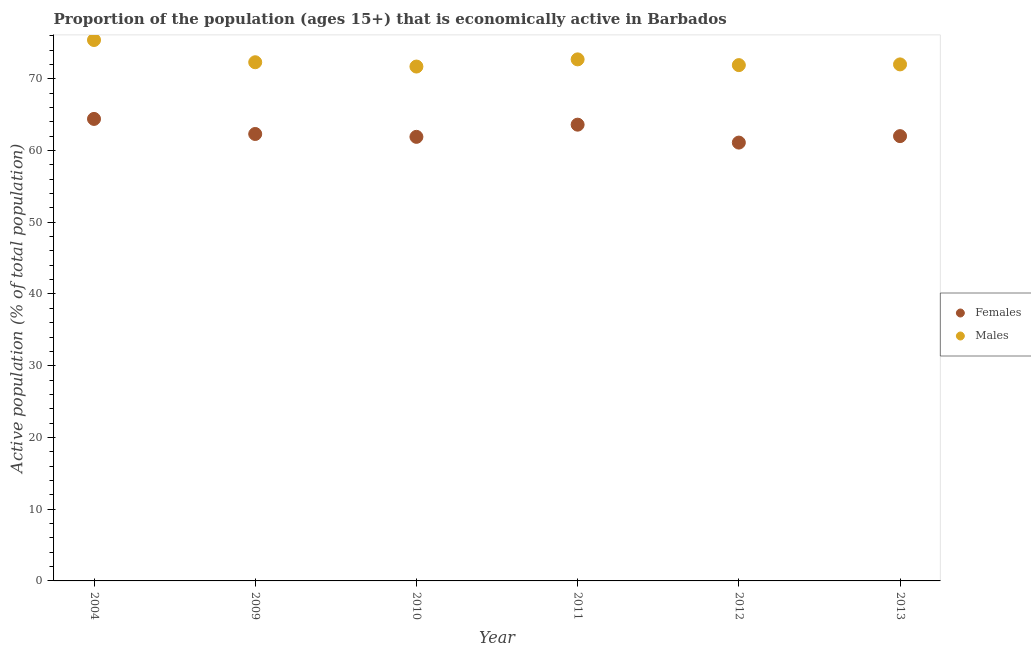How many different coloured dotlines are there?
Your response must be concise. 2. What is the percentage of economically active male population in 2004?
Your answer should be very brief. 75.4. Across all years, what is the maximum percentage of economically active male population?
Your answer should be compact. 75.4. Across all years, what is the minimum percentage of economically active female population?
Your answer should be compact. 61.1. In which year was the percentage of economically active female population maximum?
Keep it short and to the point. 2004. What is the total percentage of economically active male population in the graph?
Your response must be concise. 436. What is the difference between the percentage of economically active female population in 2010 and that in 2011?
Make the answer very short. -1.7. What is the difference between the percentage of economically active male population in 2011 and the percentage of economically active female population in 2013?
Offer a terse response. 10.7. What is the average percentage of economically active male population per year?
Make the answer very short. 72.67. In the year 2011, what is the difference between the percentage of economically active female population and percentage of economically active male population?
Your answer should be very brief. -9.1. In how many years, is the percentage of economically active female population greater than 64 %?
Ensure brevity in your answer.  1. What is the ratio of the percentage of economically active male population in 2004 to that in 2010?
Your answer should be very brief. 1.05. Is the percentage of economically active male population in 2004 less than that in 2012?
Provide a short and direct response. No. Is the difference between the percentage of economically active female population in 2010 and 2011 greater than the difference between the percentage of economically active male population in 2010 and 2011?
Ensure brevity in your answer.  No. What is the difference between the highest and the second highest percentage of economically active female population?
Your answer should be compact. 0.8. What is the difference between the highest and the lowest percentage of economically active female population?
Keep it short and to the point. 3.3. Does the percentage of economically active male population monotonically increase over the years?
Offer a very short reply. No. Is the percentage of economically active male population strictly greater than the percentage of economically active female population over the years?
Your answer should be compact. Yes. What is the difference between two consecutive major ticks on the Y-axis?
Keep it short and to the point. 10. Where does the legend appear in the graph?
Provide a succinct answer. Center right. How are the legend labels stacked?
Your response must be concise. Vertical. What is the title of the graph?
Provide a succinct answer. Proportion of the population (ages 15+) that is economically active in Barbados. What is the label or title of the Y-axis?
Your answer should be compact. Active population (% of total population). What is the Active population (% of total population) in Females in 2004?
Keep it short and to the point. 64.4. What is the Active population (% of total population) of Males in 2004?
Your answer should be very brief. 75.4. What is the Active population (% of total population) of Females in 2009?
Your answer should be compact. 62.3. What is the Active population (% of total population) of Males in 2009?
Provide a succinct answer. 72.3. What is the Active population (% of total population) of Females in 2010?
Offer a very short reply. 61.9. What is the Active population (% of total population) of Males in 2010?
Your response must be concise. 71.7. What is the Active population (% of total population) of Females in 2011?
Provide a short and direct response. 63.6. What is the Active population (% of total population) of Males in 2011?
Offer a very short reply. 72.7. What is the Active population (% of total population) of Females in 2012?
Provide a short and direct response. 61.1. What is the Active population (% of total population) of Males in 2012?
Provide a short and direct response. 71.9. What is the Active population (% of total population) of Males in 2013?
Provide a succinct answer. 72. Across all years, what is the maximum Active population (% of total population) of Females?
Give a very brief answer. 64.4. Across all years, what is the maximum Active population (% of total population) in Males?
Your response must be concise. 75.4. Across all years, what is the minimum Active population (% of total population) in Females?
Your answer should be compact. 61.1. Across all years, what is the minimum Active population (% of total population) of Males?
Provide a succinct answer. 71.7. What is the total Active population (% of total population) of Females in the graph?
Ensure brevity in your answer.  375.3. What is the total Active population (% of total population) in Males in the graph?
Your response must be concise. 436. What is the difference between the Active population (% of total population) of Females in 2004 and that in 2009?
Offer a terse response. 2.1. What is the difference between the Active population (% of total population) in Females in 2004 and that in 2010?
Provide a short and direct response. 2.5. What is the difference between the Active population (% of total population) in Females in 2004 and that in 2012?
Your answer should be compact. 3.3. What is the difference between the Active population (% of total population) of Males in 2004 and that in 2012?
Your response must be concise. 3.5. What is the difference between the Active population (% of total population) in Males in 2009 and that in 2010?
Your response must be concise. 0.6. What is the difference between the Active population (% of total population) of Males in 2009 and that in 2011?
Make the answer very short. -0.4. What is the difference between the Active population (% of total population) in Females in 2009 and that in 2012?
Offer a terse response. 1.2. What is the difference between the Active population (% of total population) of Males in 2009 and that in 2012?
Provide a short and direct response. 0.4. What is the difference between the Active population (% of total population) of Females in 2009 and that in 2013?
Keep it short and to the point. 0.3. What is the difference between the Active population (% of total population) of Males in 2009 and that in 2013?
Provide a succinct answer. 0.3. What is the difference between the Active population (% of total population) in Males in 2010 and that in 2011?
Provide a short and direct response. -1. What is the difference between the Active population (% of total population) in Females in 2010 and that in 2012?
Offer a very short reply. 0.8. What is the difference between the Active population (% of total population) of Males in 2010 and that in 2012?
Your answer should be compact. -0.2. What is the difference between the Active population (% of total population) of Females in 2010 and that in 2013?
Make the answer very short. -0.1. What is the difference between the Active population (% of total population) in Males in 2010 and that in 2013?
Make the answer very short. -0.3. What is the difference between the Active population (% of total population) in Males in 2011 and that in 2012?
Offer a terse response. 0.8. What is the difference between the Active population (% of total population) in Females in 2011 and that in 2013?
Your answer should be very brief. 1.6. What is the difference between the Active population (% of total population) in Males in 2012 and that in 2013?
Ensure brevity in your answer.  -0.1. What is the difference between the Active population (% of total population) in Females in 2004 and the Active population (% of total population) in Males in 2009?
Your response must be concise. -7.9. What is the difference between the Active population (% of total population) of Females in 2004 and the Active population (% of total population) of Males in 2010?
Ensure brevity in your answer.  -7.3. What is the difference between the Active population (% of total population) in Females in 2004 and the Active population (% of total population) in Males in 2012?
Keep it short and to the point. -7.5. What is the difference between the Active population (% of total population) of Females in 2004 and the Active population (% of total population) of Males in 2013?
Your response must be concise. -7.6. What is the difference between the Active population (% of total population) of Females in 2009 and the Active population (% of total population) of Males in 2010?
Offer a very short reply. -9.4. What is the difference between the Active population (% of total population) of Females in 2009 and the Active population (% of total population) of Males in 2012?
Provide a succinct answer. -9.6. What is the difference between the Active population (% of total population) in Females in 2010 and the Active population (% of total population) in Males in 2012?
Make the answer very short. -10. What is the difference between the Active population (% of total population) in Females in 2010 and the Active population (% of total population) in Males in 2013?
Offer a terse response. -10.1. What is the average Active population (% of total population) of Females per year?
Offer a terse response. 62.55. What is the average Active population (% of total population) in Males per year?
Give a very brief answer. 72.67. In the year 2010, what is the difference between the Active population (% of total population) in Females and Active population (% of total population) in Males?
Ensure brevity in your answer.  -9.8. What is the ratio of the Active population (% of total population) in Females in 2004 to that in 2009?
Make the answer very short. 1.03. What is the ratio of the Active population (% of total population) of Males in 2004 to that in 2009?
Your answer should be very brief. 1.04. What is the ratio of the Active population (% of total population) in Females in 2004 to that in 2010?
Ensure brevity in your answer.  1.04. What is the ratio of the Active population (% of total population) in Males in 2004 to that in 2010?
Provide a short and direct response. 1.05. What is the ratio of the Active population (% of total population) in Females in 2004 to that in 2011?
Your answer should be compact. 1.01. What is the ratio of the Active population (% of total population) in Males in 2004 to that in 2011?
Your answer should be very brief. 1.04. What is the ratio of the Active population (% of total population) in Females in 2004 to that in 2012?
Your response must be concise. 1.05. What is the ratio of the Active population (% of total population) in Males in 2004 to that in 2012?
Offer a very short reply. 1.05. What is the ratio of the Active population (% of total population) of Females in 2004 to that in 2013?
Your answer should be compact. 1.04. What is the ratio of the Active population (% of total population) of Males in 2004 to that in 2013?
Provide a short and direct response. 1.05. What is the ratio of the Active population (% of total population) of Females in 2009 to that in 2010?
Your answer should be very brief. 1.01. What is the ratio of the Active population (% of total population) of Males in 2009 to that in 2010?
Offer a very short reply. 1.01. What is the ratio of the Active population (% of total population) in Females in 2009 to that in 2011?
Offer a very short reply. 0.98. What is the ratio of the Active population (% of total population) of Males in 2009 to that in 2011?
Provide a succinct answer. 0.99. What is the ratio of the Active population (% of total population) in Females in 2009 to that in 2012?
Provide a succinct answer. 1.02. What is the ratio of the Active population (% of total population) of Males in 2009 to that in 2012?
Ensure brevity in your answer.  1.01. What is the ratio of the Active population (% of total population) of Females in 2009 to that in 2013?
Offer a very short reply. 1. What is the ratio of the Active population (% of total population) in Males in 2009 to that in 2013?
Make the answer very short. 1. What is the ratio of the Active population (% of total population) in Females in 2010 to that in 2011?
Ensure brevity in your answer.  0.97. What is the ratio of the Active population (% of total population) in Males in 2010 to that in 2011?
Provide a succinct answer. 0.99. What is the ratio of the Active population (% of total population) in Females in 2010 to that in 2012?
Your answer should be very brief. 1.01. What is the ratio of the Active population (% of total population) of Females in 2010 to that in 2013?
Your response must be concise. 1. What is the ratio of the Active population (% of total population) in Females in 2011 to that in 2012?
Ensure brevity in your answer.  1.04. What is the ratio of the Active population (% of total population) in Males in 2011 to that in 2012?
Keep it short and to the point. 1.01. What is the ratio of the Active population (% of total population) in Females in 2011 to that in 2013?
Your response must be concise. 1.03. What is the ratio of the Active population (% of total population) in Males in 2011 to that in 2013?
Provide a short and direct response. 1.01. What is the ratio of the Active population (% of total population) of Females in 2012 to that in 2013?
Ensure brevity in your answer.  0.99. What is the ratio of the Active population (% of total population) of Males in 2012 to that in 2013?
Make the answer very short. 1. What is the difference between the highest and the second highest Active population (% of total population) of Females?
Your response must be concise. 0.8. What is the difference between the highest and the lowest Active population (% of total population) of Females?
Offer a terse response. 3.3. What is the difference between the highest and the lowest Active population (% of total population) in Males?
Offer a very short reply. 3.7. 